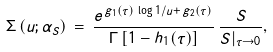Convert formula to latex. <formula><loc_0><loc_0><loc_500><loc_500>\Sigma \left ( u ; \alpha _ { S } \right ) \, = \, \frac { e ^ { \, g _ { 1 } ( \tau ) \, \log 1 / u + \, g _ { 2 } ( \tau ) } } { \Gamma \left [ 1 - h _ { 1 } ( \tau ) \right ] } \, \frac { S } { S | _ { \tau \rightarrow 0 } } ,</formula> 